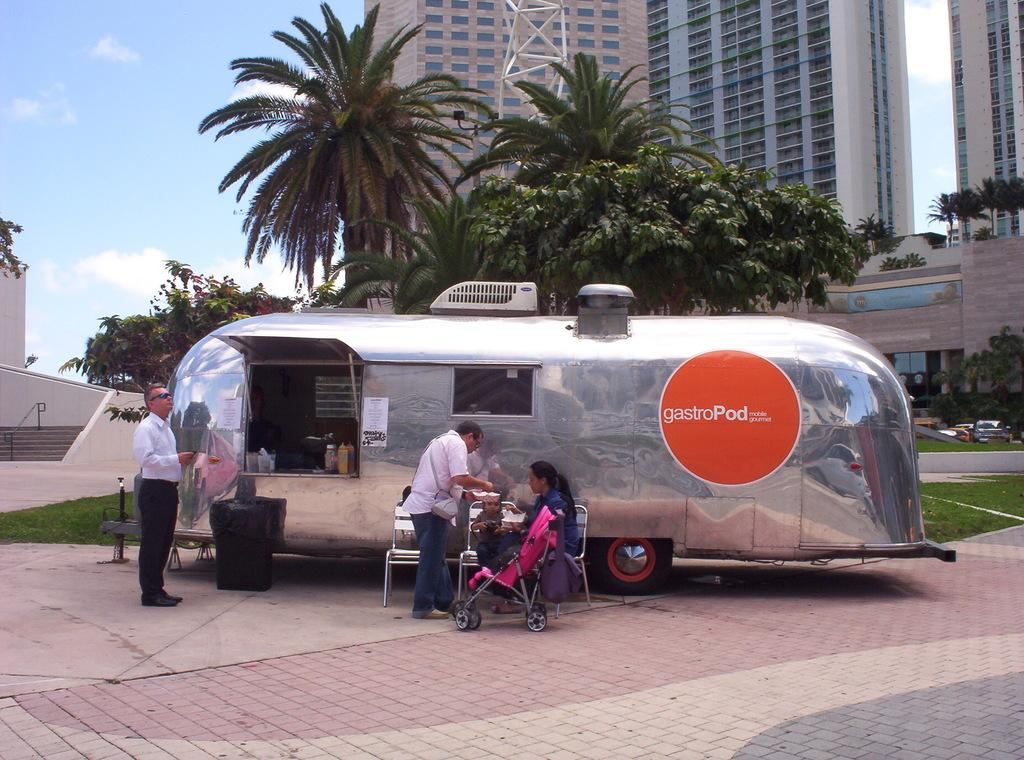What can be seen in the middle of the image? In the middle of the image, there are trees, buildings, grass, vehicles, chairs, and people. There is also a dustbin and various other objects. Can you describe the environment in the middle of the image? The environment in the middle of the image consists of a mix of natural elements like trees and grass, as well as man-made structures like buildings and vehicles. What is present at the bottom of the image? At the bottom of the image, there is a floor. What is visible at the top of the image? The top of the image contains the sky. How does the jellyfish affect the environment in the image? There are no jellyfish present in the image, so it cannot have any effect on the environment depicted. 